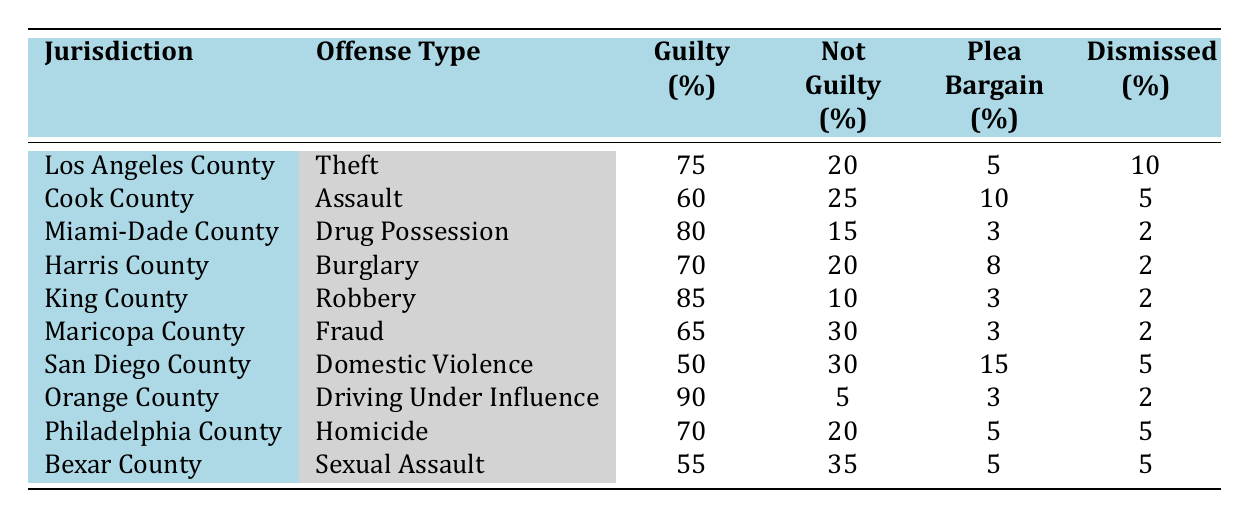What is the guilty percentage for Theft in Los Angeles County? The table shows that for Theft in Los Angeles County, the guilty percentage is directly listed as 75%.
Answer: 75% Which jurisdiction has the highest percentage of not guilty verdicts? By comparing the 'Not Guilty' columns for all jurisdictions, San Diego County has the highest percentage at 30%.
Answer: San Diego County What is the plea bargain percentage for Fraud in Maricopa County? The table indicates that the plea bargain percentage for Fraud in Maricopa County is 3%.
Answer: 3% What is the difference in guilty percentages between Robbery in King County and Assault in Cook County? The guilty percentage for Robbery in King County is 85%, and for Assault in Cook County, it is 60%. The difference is calculated as 85% - 60% = 25%.
Answer: 25% Which offense type in this table has the lowest guilty percentage? By examining the 'Guilty' percentages, Domestic Violence in San Diego County has the lowest at 50%.
Answer: Domestic Violence Is the percentage of guilty verdicts for Drug Possession in Miami-Dade County higher than for Theft in Los Angeles County? The table shows 80% for Drug Possession in Miami-Dade County and 75% for Theft in Los Angeles County. Since 80% is greater than 75%, the statement is true.
Answer: Yes What is the average guilty percentage across all jurisdictions listed? To calculate the average, sum all guilty percentages: 75 + 60 + 80 + 70 + 85 + 65 + 50 + 90 + 70 + 55 =  855, then divide by the number of jurisdictions (10): 855 / 10 = 85.5%.
Answer: 85.5% How many jurisdictions have a plea bargain percentage greater than 5%? By reviewing the plea bargain percentages, they are 10%, 8%, 15%, and 5%. That means four jurisdictions have a percentage greater than 5%.
Answer: 4 Which offense type had the highest dismissal percentage? By comparing the dismissal percentages, Theft in Los Angeles County, Assault in Cook County, Domestic Violence in San Diego County, Homicide in Philadelphia County, and Sexual Assault in Bexar County all have a dismissal percentage of 5%, which is the highest.
Answer: Theft, Assault, Domestic Violence, Homicide, Sexual Assault What is the sum of the not guilty percentages for Drug Possession and Domestic Violence? The not guilty percentage for Drug Possession is 15%, and for Domestic Violence, it is 30%. The sum is calculated as 15% + 30% = 45%.
Answer: 45% 